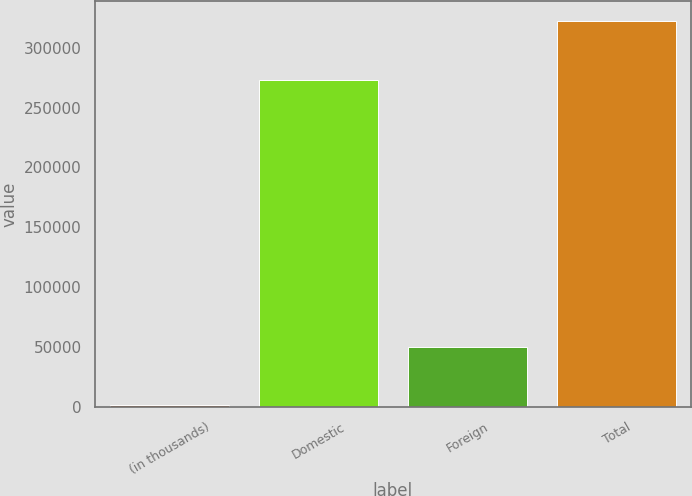<chart> <loc_0><loc_0><loc_500><loc_500><bar_chart><fcel>(in thousands)<fcel>Domestic<fcel>Foreign<fcel>Total<nl><fcel>2013<fcel>272569<fcel>49920<fcel>322489<nl></chart> 